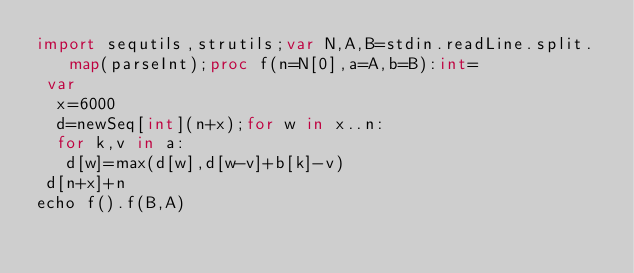<code> <loc_0><loc_0><loc_500><loc_500><_Nim_>import sequtils,strutils;var N,A,B=stdin.readLine.split.map(parseInt);proc f(n=N[0],a=A,b=B):int=
 var
  x=6000
  d=newSeq[int](n+x);for w in x..n:
  for k,v in a:
   d[w]=max(d[w],d[w-v]+b[k]-v)
 d[n+x]+n
echo f().f(B,A)
</code> 